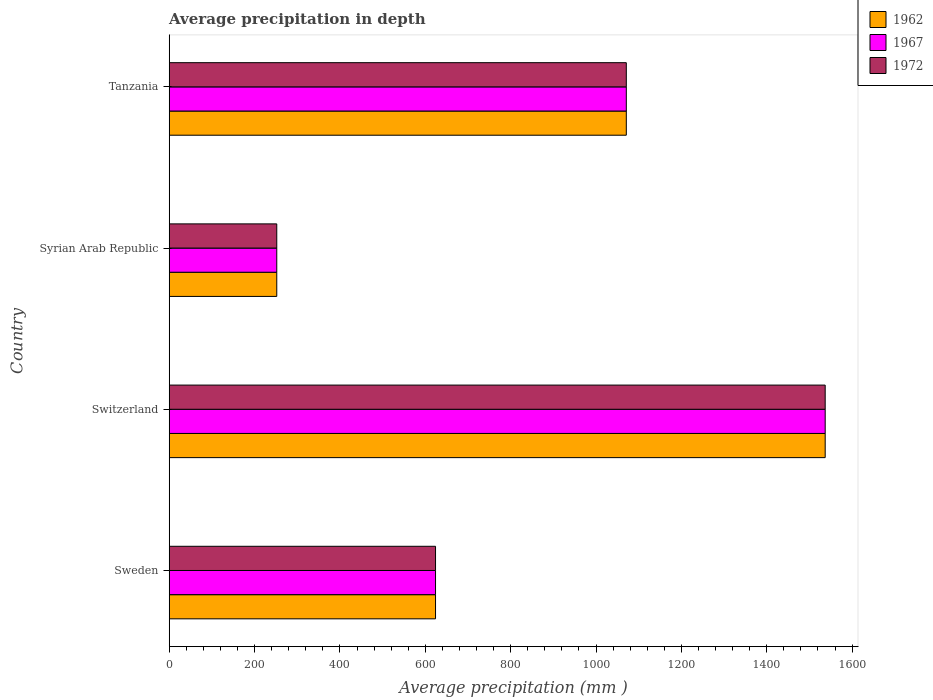How many different coloured bars are there?
Keep it short and to the point. 3. How many groups of bars are there?
Your answer should be compact. 4. Are the number of bars per tick equal to the number of legend labels?
Keep it short and to the point. Yes. What is the average precipitation in 1972 in Sweden?
Offer a terse response. 624. Across all countries, what is the maximum average precipitation in 1962?
Give a very brief answer. 1537. Across all countries, what is the minimum average precipitation in 1962?
Ensure brevity in your answer.  252. In which country was the average precipitation in 1972 maximum?
Keep it short and to the point. Switzerland. In which country was the average precipitation in 1962 minimum?
Your response must be concise. Syrian Arab Republic. What is the total average precipitation in 1972 in the graph?
Provide a succinct answer. 3484. What is the difference between the average precipitation in 1972 in Sweden and that in Tanzania?
Your answer should be compact. -447. What is the difference between the average precipitation in 1972 in Switzerland and the average precipitation in 1962 in Sweden?
Provide a succinct answer. 913. What is the average average precipitation in 1967 per country?
Make the answer very short. 871. What is the difference between the average precipitation in 1972 and average precipitation in 1967 in Switzerland?
Offer a terse response. 0. What is the ratio of the average precipitation in 1967 in Switzerland to that in Tanzania?
Your answer should be very brief. 1.44. Is the average precipitation in 1972 in Syrian Arab Republic less than that in Tanzania?
Your answer should be very brief. Yes. Is the difference between the average precipitation in 1972 in Sweden and Tanzania greater than the difference between the average precipitation in 1967 in Sweden and Tanzania?
Provide a short and direct response. No. What is the difference between the highest and the second highest average precipitation in 1972?
Your answer should be very brief. 466. What is the difference between the highest and the lowest average precipitation in 1972?
Give a very brief answer. 1285. In how many countries, is the average precipitation in 1967 greater than the average average precipitation in 1967 taken over all countries?
Your answer should be compact. 2. What does the 2nd bar from the bottom in Tanzania represents?
Provide a short and direct response. 1967. What is the difference between two consecutive major ticks on the X-axis?
Keep it short and to the point. 200. Are the values on the major ticks of X-axis written in scientific E-notation?
Keep it short and to the point. No. Does the graph contain grids?
Offer a terse response. No. What is the title of the graph?
Provide a short and direct response. Average precipitation in depth. What is the label or title of the X-axis?
Your answer should be very brief. Average precipitation (mm ). What is the Average precipitation (mm ) of 1962 in Sweden?
Your answer should be compact. 624. What is the Average precipitation (mm ) in 1967 in Sweden?
Offer a terse response. 624. What is the Average precipitation (mm ) of 1972 in Sweden?
Provide a succinct answer. 624. What is the Average precipitation (mm ) of 1962 in Switzerland?
Make the answer very short. 1537. What is the Average precipitation (mm ) of 1967 in Switzerland?
Make the answer very short. 1537. What is the Average precipitation (mm ) of 1972 in Switzerland?
Make the answer very short. 1537. What is the Average precipitation (mm ) of 1962 in Syrian Arab Republic?
Your answer should be very brief. 252. What is the Average precipitation (mm ) of 1967 in Syrian Arab Republic?
Provide a succinct answer. 252. What is the Average precipitation (mm ) of 1972 in Syrian Arab Republic?
Provide a succinct answer. 252. What is the Average precipitation (mm ) in 1962 in Tanzania?
Give a very brief answer. 1071. What is the Average precipitation (mm ) in 1967 in Tanzania?
Provide a short and direct response. 1071. What is the Average precipitation (mm ) of 1972 in Tanzania?
Give a very brief answer. 1071. Across all countries, what is the maximum Average precipitation (mm ) in 1962?
Make the answer very short. 1537. Across all countries, what is the maximum Average precipitation (mm ) in 1967?
Your response must be concise. 1537. Across all countries, what is the maximum Average precipitation (mm ) in 1972?
Your response must be concise. 1537. Across all countries, what is the minimum Average precipitation (mm ) of 1962?
Your answer should be compact. 252. Across all countries, what is the minimum Average precipitation (mm ) in 1967?
Offer a very short reply. 252. Across all countries, what is the minimum Average precipitation (mm ) of 1972?
Give a very brief answer. 252. What is the total Average precipitation (mm ) in 1962 in the graph?
Offer a terse response. 3484. What is the total Average precipitation (mm ) of 1967 in the graph?
Your response must be concise. 3484. What is the total Average precipitation (mm ) in 1972 in the graph?
Give a very brief answer. 3484. What is the difference between the Average precipitation (mm ) of 1962 in Sweden and that in Switzerland?
Your answer should be very brief. -913. What is the difference between the Average precipitation (mm ) in 1967 in Sweden and that in Switzerland?
Give a very brief answer. -913. What is the difference between the Average precipitation (mm ) of 1972 in Sweden and that in Switzerland?
Ensure brevity in your answer.  -913. What is the difference between the Average precipitation (mm ) in 1962 in Sweden and that in Syrian Arab Republic?
Your answer should be compact. 372. What is the difference between the Average precipitation (mm ) of 1967 in Sweden and that in Syrian Arab Republic?
Offer a terse response. 372. What is the difference between the Average precipitation (mm ) of 1972 in Sweden and that in Syrian Arab Republic?
Provide a short and direct response. 372. What is the difference between the Average precipitation (mm ) of 1962 in Sweden and that in Tanzania?
Your answer should be very brief. -447. What is the difference between the Average precipitation (mm ) in 1967 in Sweden and that in Tanzania?
Your response must be concise. -447. What is the difference between the Average precipitation (mm ) in 1972 in Sweden and that in Tanzania?
Provide a short and direct response. -447. What is the difference between the Average precipitation (mm ) of 1962 in Switzerland and that in Syrian Arab Republic?
Ensure brevity in your answer.  1285. What is the difference between the Average precipitation (mm ) in 1967 in Switzerland and that in Syrian Arab Republic?
Ensure brevity in your answer.  1285. What is the difference between the Average precipitation (mm ) of 1972 in Switzerland and that in Syrian Arab Republic?
Provide a short and direct response. 1285. What is the difference between the Average precipitation (mm ) of 1962 in Switzerland and that in Tanzania?
Your response must be concise. 466. What is the difference between the Average precipitation (mm ) of 1967 in Switzerland and that in Tanzania?
Make the answer very short. 466. What is the difference between the Average precipitation (mm ) of 1972 in Switzerland and that in Tanzania?
Provide a short and direct response. 466. What is the difference between the Average precipitation (mm ) in 1962 in Syrian Arab Republic and that in Tanzania?
Provide a succinct answer. -819. What is the difference between the Average precipitation (mm ) of 1967 in Syrian Arab Republic and that in Tanzania?
Your answer should be very brief. -819. What is the difference between the Average precipitation (mm ) of 1972 in Syrian Arab Republic and that in Tanzania?
Your response must be concise. -819. What is the difference between the Average precipitation (mm ) of 1962 in Sweden and the Average precipitation (mm ) of 1967 in Switzerland?
Ensure brevity in your answer.  -913. What is the difference between the Average precipitation (mm ) in 1962 in Sweden and the Average precipitation (mm ) in 1972 in Switzerland?
Your answer should be very brief. -913. What is the difference between the Average precipitation (mm ) of 1967 in Sweden and the Average precipitation (mm ) of 1972 in Switzerland?
Offer a terse response. -913. What is the difference between the Average precipitation (mm ) of 1962 in Sweden and the Average precipitation (mm ) of 1967 in Syrian Arab Republic?
Ensure brevity in your answer.  372. What is the difference between the Average precipitation (mm ) of 1962 in Sweden and the Average precipitation (mm ) of 1972 in Syrian Arab Republic?
Your answer should be very brief. 372. What is the difference between the Average precipitation (mm ) of 1967 in Sweden and the Average precipitation (mm ) of 1972 in Syrian Arab Republic?
Provide a succinct answer. 372. What is the difference between the Average precipitation (mm ) in 1962 in Sweden and the Average precipitation (mm ) in 1967 in Tanzania?
Provide a short and direct response. -447. What is the difference between the Average precipitation (mm ) in 1962 in Sweden and the Average precipitation (mm ) in 1972 in Tanzania?
Make the answer very short. -447. What is the difference between the Average precipitation (mm ) in 1967 in Sweden and the Average precipitation (mm ) in 1972 in Tanzania?
Offer a terse response. -447. What is the difference between the Average precipitation (mm ) in 1962 in Switzerland and the Average precipitation (mm ) in 1967 in Syrian Arab Republic?
Keep it short and to the point. 1285. What is the difference between the Average precipitation (mm ) in 1962 in Switzerland and the Average precipitation (mm ) in 1972 in Syrian Arab Republic?
Provide a succinct answer. 1285. What is the difference between the Average precipitation (mm ) of 1967 in Switzerland and the Average precipitation (mm ) of 1972 in Syrian Arab Republic?
Offer a very short reply. 1285. What is the difference between the Average precipitation (mm ) of 1962 in Switzerland and the Average precipitation (mm ) of 1967 in Tanzania?
Ensure brevity in your answer.  466. What is the difference between the Average precipitation (mm ) in 1962 in Switzerland and the Average precipitation (mm ) in 1972 in Tanzania?
Provide a short and direct response. 466. What is the difference between the Average precipitation (mm ) of 1967 in Switzerland and the Average precipitation (mm ) of 1972 in Tanzania?
Your response must be concise. 466. What is the difference between the Average precipitation (mm ) of 1962 in Syrian Arab Republic and the Average precipitation (mm ) of 1967 in Tanzania?
Ensure brevity in your answer.  -819. What is the difference between the Average precipitation (mm ) in 1962 in Syrian Arab Republic and the Average precipitation (mm ) in 1972 in Tanzania?
Your answer should be very brief. -819. What is the difference between the Average precipitation (mm ) in 1967 in Syrian Arab Republic and the Average precipitation (mm ) in 1972 in Tanzania?
Keep it short and to the point. -819. What is the average Average precipitation (mm ) in 1962 per country?
Offer a terse response. 871. What is the average Average precipitation (mm ) in 1967 per country?
Your answer should be very brief. 871. What is the average Average precipitation (mm ) of 1972 per country?
Provide a succinct answer. 871. What is the difference between the Average precipitation (mm ) in 1962 and Average precipitation (mm ) in 1972 in Sweden?
Your response must be concise. 0. What is the difference between the Average precipitation (mm ) in 1967 and Average precipitation (mm ) in 1972 in Sweden?
Your answer should be very brief. 0. What is the difference between the Average precipitation (mm ) in 1962 and Average precipitation (mm ) in 1967 in Switzerland?
Your response must be concise. 0. What is the difference between the Average precipitation (mm ) of 1962 and Average precipitation (mm ) of 1972 in Switzerland?
Make the answer very short. 0. What is the difference between the Average precipitation (mm ) of 1967 and Average precipitation (mm ) of 1972 in Switzerland?
Your answer should be compact. 0. What is the difference between the Average precipitation (mm ) in 1962 and Average precipitation (mm ) in 1967 in Syrian Arab Republic?
Give a very brief answer. 0. What is the difference between the Average precipitation (mm ) of 1962 and Average precipitation (mm ) of 1972 in Syrian Arab Republic?
Keep it short and to the point. 0. What is the difference between the Average precipitation (mm ) of 1967 and Average precipitation (mm ) of 1972 in Syrian Arab Republic?
Provide a short and direct response. 0. What is the difference between the Average precipitation (mm ) in 1962 and Average precipitation (mm ) in 1967 in Tanzania?
Offer a very short reply. 0. What is the ratio of the Average precipitation (mm ) of 1962 in Sweden to that in Switzerland?
Your answer should be compact. 0.41. What is the ratio of the Average precipitation (mm ) of 1967 in Sweden to that in Switzerland?
Provide a short and direct response. 0.41. What is the ratio of the Average precipitation (mm ) of 1972 in Sweden to that in Switzerland?
Your answer should be very brief. 0.41. What is the ratio of the Average precipitation (mm ) in 1962 in Sweden to that in Syrian Arab Republic?
Offer a very short reply. 2.48. What is the ratio of the Average precipitation (mm ) in 1967 in Sweden to that in Syrian Arab Republic?
Provide a short and direct response. 2.48. What is the ratio of the Average precipitation (mm ) of 1972 in Sweden to that in Syrian Arab Republic?
Give a very brief answer. 2.48. What is the ratio of the Average precipitation (mm ) of 1962 in Sweden to that in Tanzania?
Ensure brevity in your answer.  0.58. What is the ratio of the Average precipitation (mm ) in 1967 in Sweden to that in Tanzania?
Ensure brevity in your answer.  0.58. What is the ratio of the Average precipitation (mm ) of 1972 in Sweden to that in Tanzania?
Offer a very short reply. 0.58. What is the ratio of the Average precipitation (mm ) of 1962 in Switzerland to that in Syrian Arab Republic?
Your answer should be very brief. 6.1. What is the ratio of the Average precipitation (mm ) of 1967 in Switzerland to that in Syrian Arab Republic?
Ensure brevity in your answer.  6.1. What is the ratio of the Average precipitation (mm ) of 1972 in Switzerland to that in Syrian Arab Republic?
Provide a succinct answer. 6.1. What is the ratio of the Average precipitation (mm ) of 1962 in Switzerland to that in Tanzania?
Provide a succinct answer. 1.44. What is the ratio of the Average precipitation (mm ) in 1967 in Switzerland to that in Tanzania?
Offer a terse response. 1.44. What is the ratio of the Average precipitation (mm ) of 1972 in Switzerland to that in Tanzania?
Give a very brief answer. 1.44. What is the ratio of the Average precipitation (mm ) of 1962 in Syrian Arab Republic to that in Tanzania?
Offer a very short reply. 0.24. What is the ratio of the Average precipitation (mm ) in 1967 in Syrian Arab Republic to that in Tanzania?
Make the answer very short. 0.24. What is the ratio of the Average precipitation (mm ) in 1972 in Syrian Arab Republic to that in Tanzania?
Offer a very short reply. 0.24. What is the difference between the highest and the second highest Average precipitation (mm ) in 1962?
Ensure brevity in your answer.  466. What is the difference between the highest and the second highest Average precipitation (mm ) in 1967?
Make the answer very short. 466. What is the difference between the highest and the second highest Average precipitation (mm ) in 1972?
Keep it short and to the point. 466. What is the difference between the highest and the lowest Average precipitation (mm ) of 1962?
Provide a succinct answer. 1285. What is the difference between the highest and the lowest Average precipitation (mm ) of 1967?
Your answer should be compact. 1285. What is the difference between the highest and the lowest Average precipitation (mm ) of 1972?
Your answer should be very brief. 1285. 